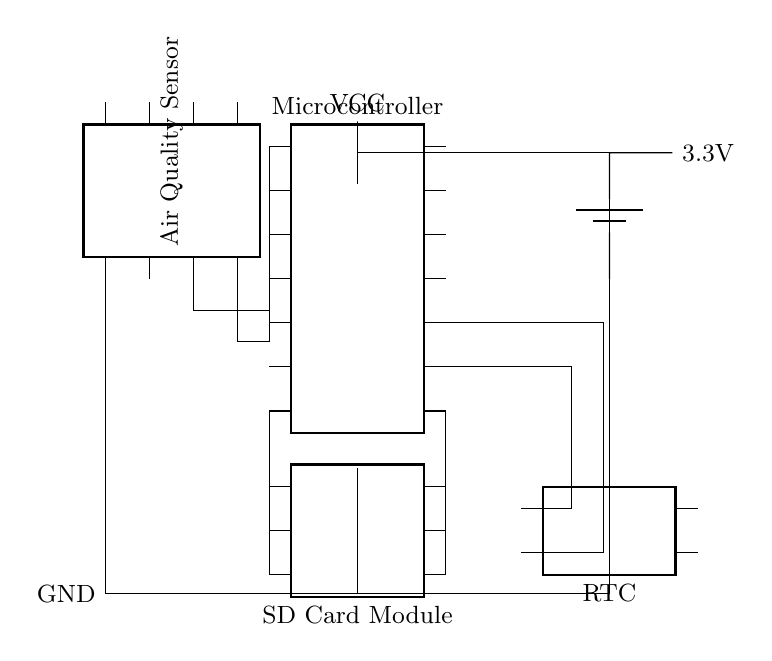What is the main component that measures air quality? The component that measures air quality in the circuit is the air quality sensor, which is represented at the left side of the diagram.
Answer: Air Quality Sensor What type of memory storage is used in this circuit? The circuit utilizes an SD card module for memory storage, indicated by the chip labeled "SD Card Module" located below the microcontroller.
Answer: SD card What is the power supply voltage for this device? The circuit is powered by a 3.3V battery, which is shown on the right side of the diagram next to the battery symbol.
Answer: 3.3V What is the purpose of the RTC in the circuit? The RTC, or Real-Time Clock, is used to keep track of time, allowing for timestamping of air quality data recorded on the SD card. This is indicated by its connection to the microcontroller and labeled function in the diagram.
Answer: Keep time How many pins does the microcontroller have? The microcontroller is represented as a chip with 14 pins, as shown in the circuit diagram where the number of pins is indicated.
Answer: 14 pins What type of connection is made between the sensor and microcontroller? The connection between the air quality sensor and the microcontroller is a wired connection, which is shown by straight lines representing wires in the circuit diagram.
Answer: Wired connection Which component provides the timing signals to the microcontroller? The RTC, or Real-Time Clock, provides timing signals to the microcontroller, as indicated by the connections from the microcontroller pins to the RTC pins.
Answer: RTC 